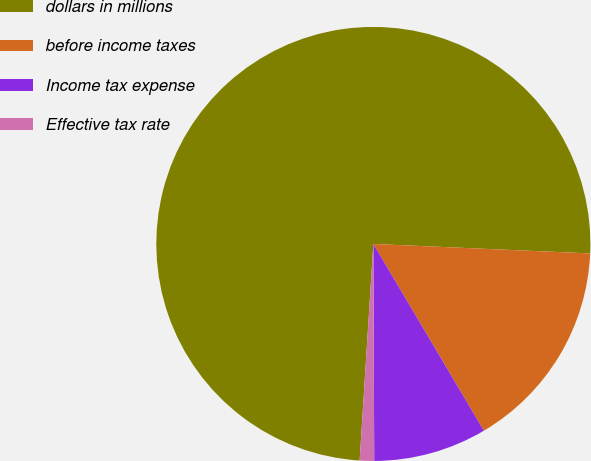Convert chart to OTSL. <chart><loc_0><loc_0><loc_500><loc_500><pie_chart><fcel>dollars in millions<fcel>before income taxes<fcel>Income tax expense<fcel>Effective tax rate<nl><fcel>74.69%<fcel>15.8%<fcel>8.44%<fcel>1.07%<nl></chart> 